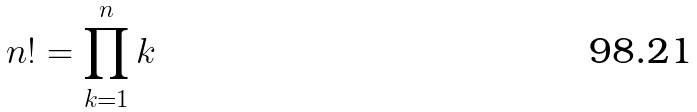Convert formula to latex. <formula><loc_0><loc_0><loc_500><loc_500>n ! = \prod _ { k = 1 } ^ { n } k</formula> 